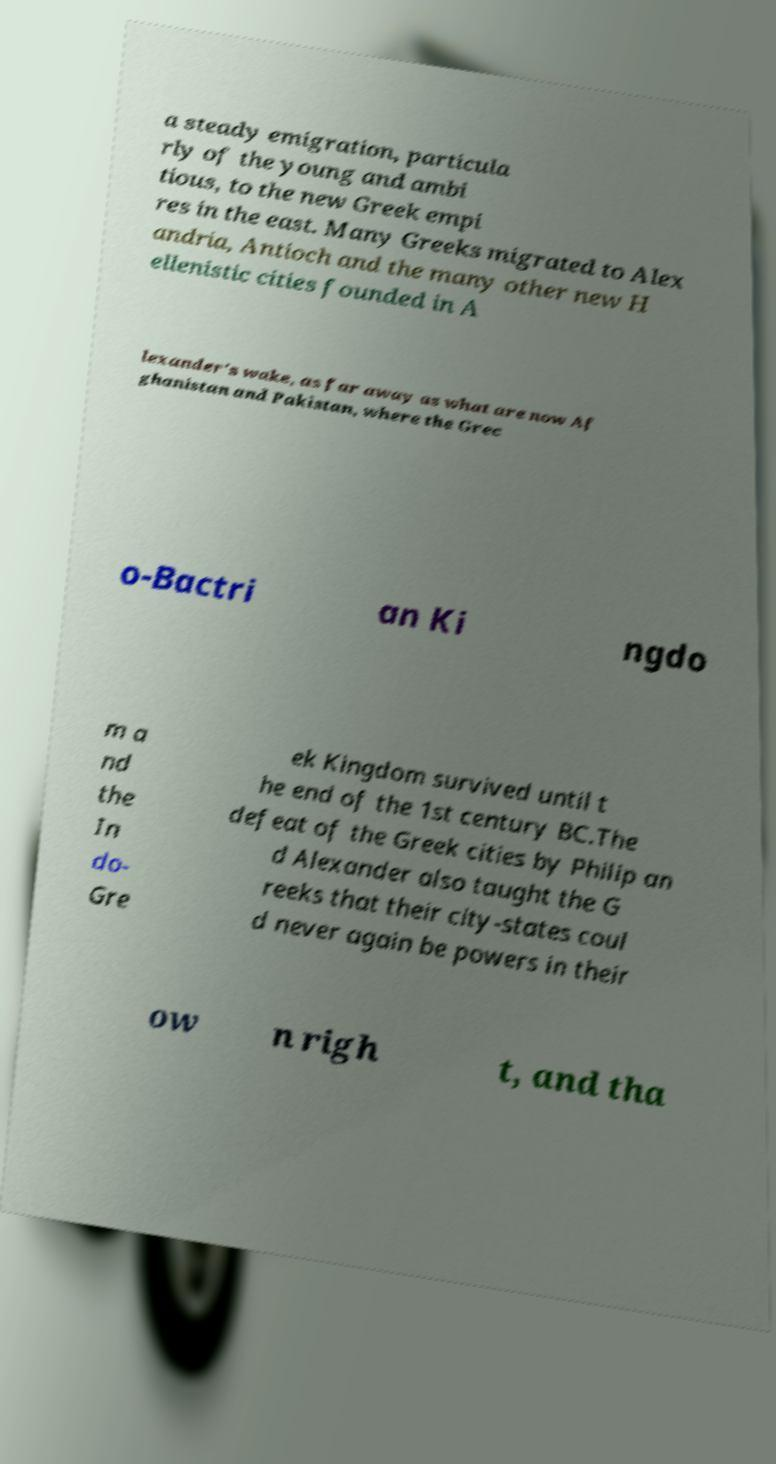Could you assist in decoding the text presented in this image and type it out clearly? a steady emigration, particula rly of the young and ambi tious, to the new Greek empi res in the east. Many Greeks migrated to Alex andria, Antioch and the many other new H ellenistic cities founded in A lexander's wake, as far away as what are now Af ghanistan and Pakistan, where the Grec o-Bactri an Ki ngdo m a nd the In do- Gre ek Kingdom survived until t he end of the 1st century BC.The defeat of the Greek cities by Philip an d Alexander also taught the G reeks that their city-states coul d never again be powers in their ow n righ t, and tha 